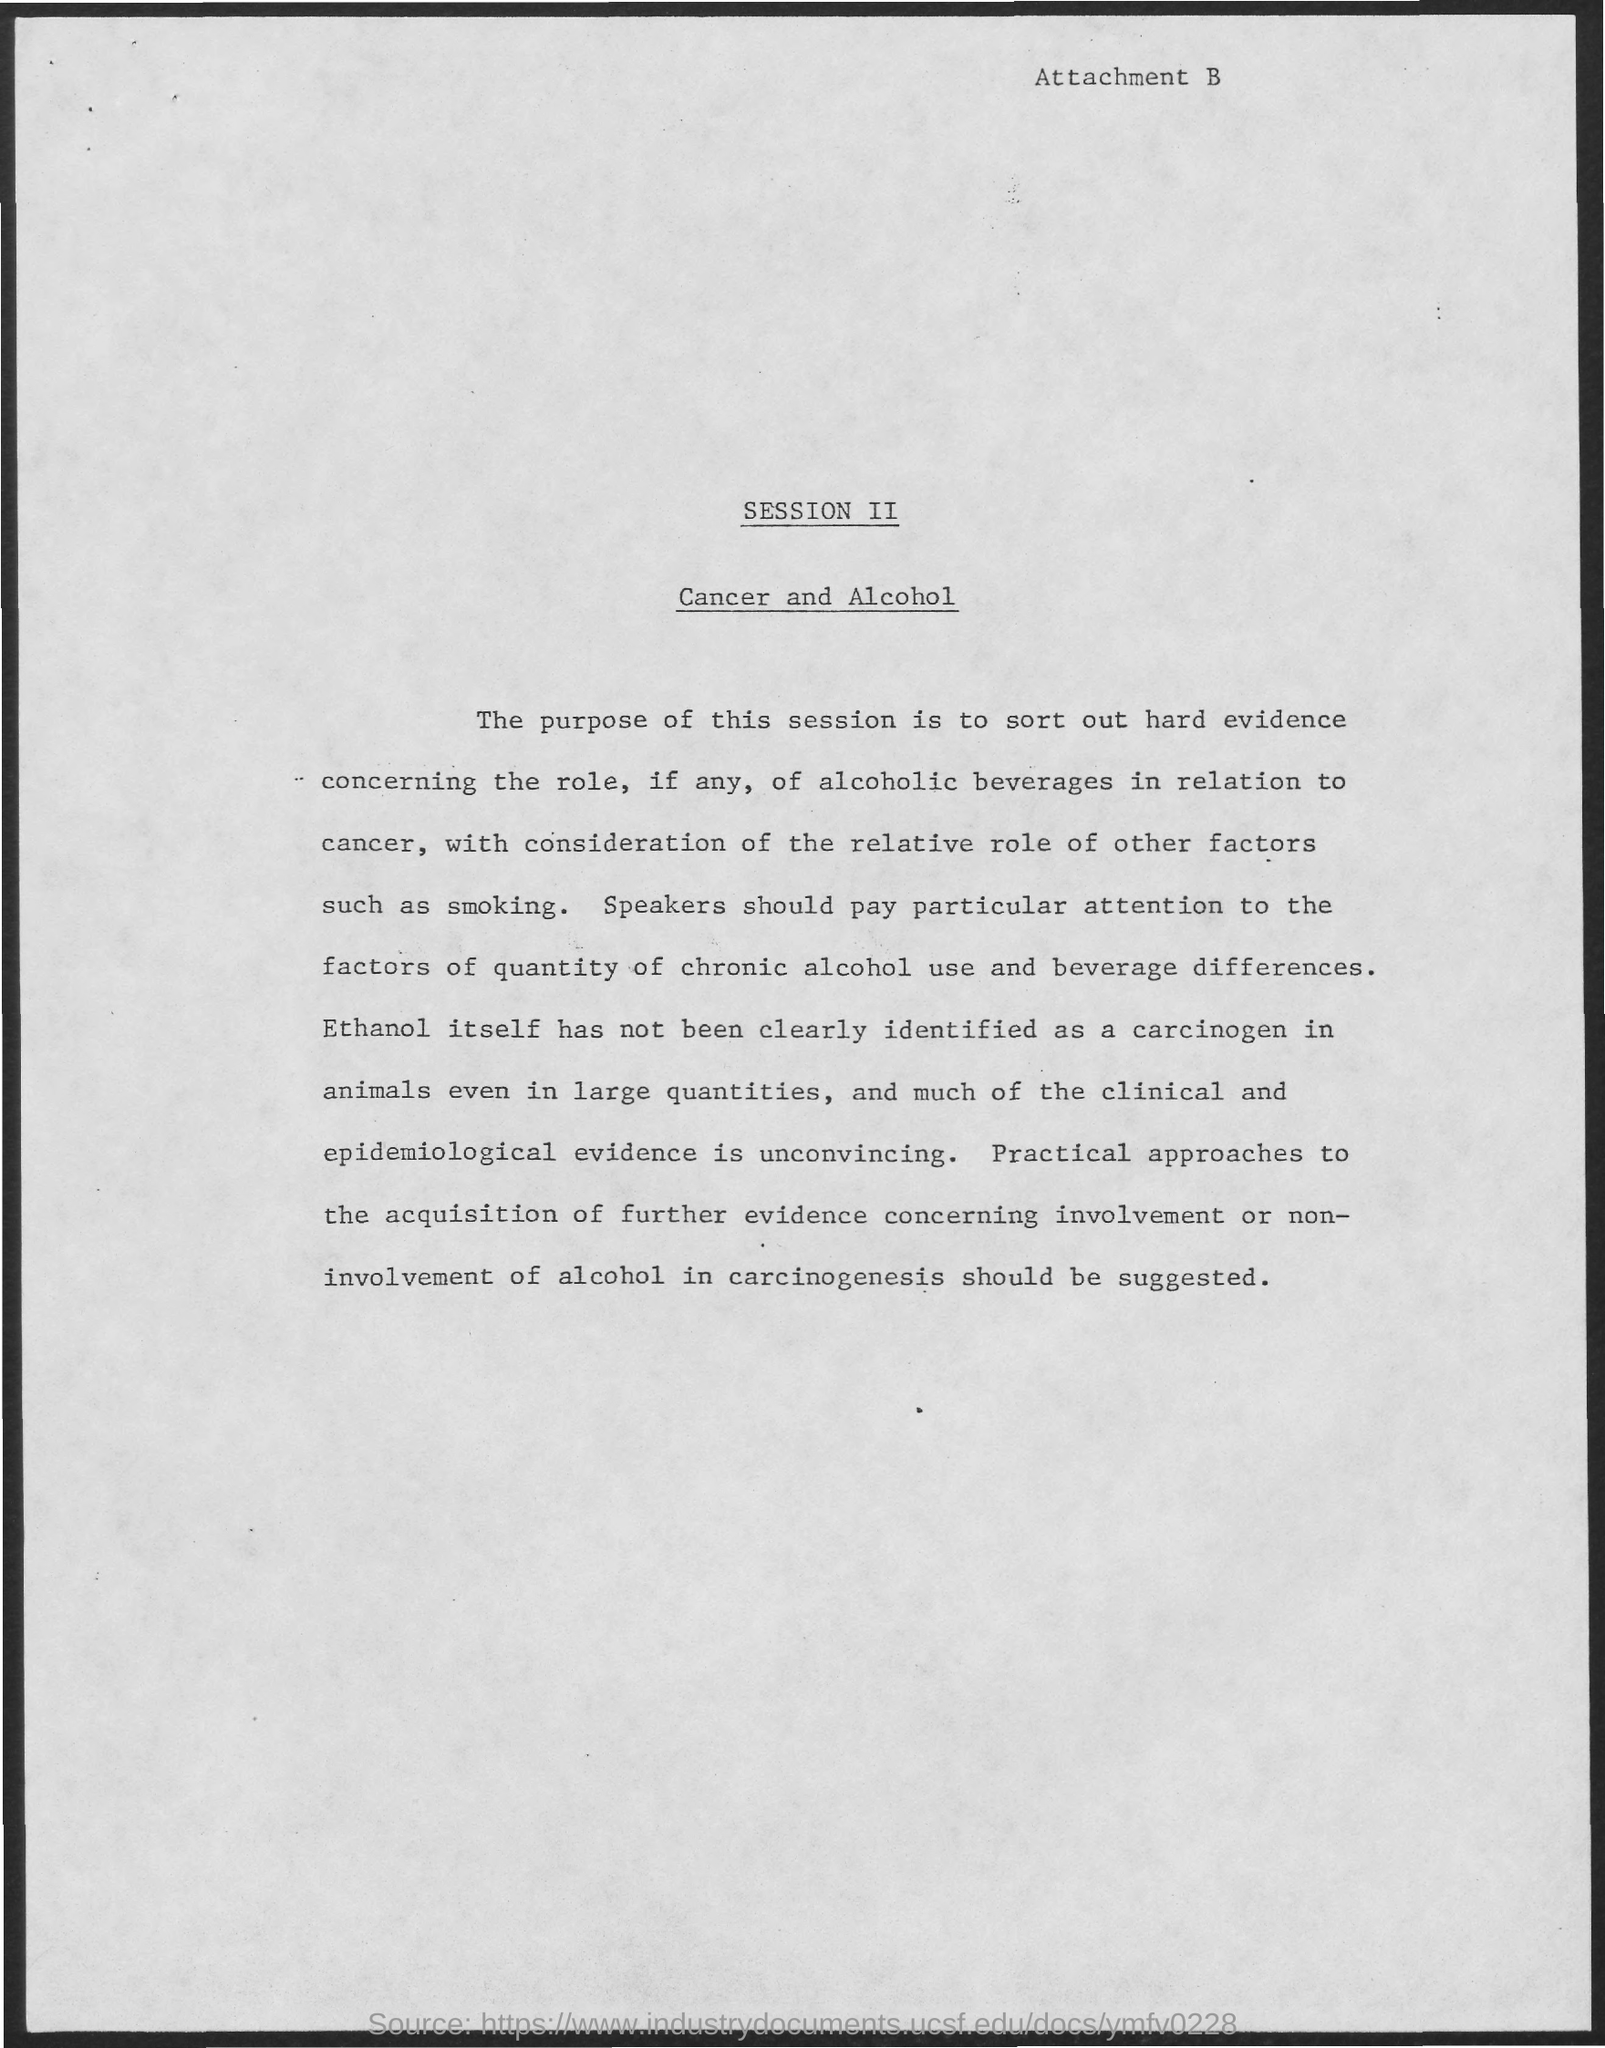What is written in the top of the document ?
Ensure brevity in your answer.  Attachment B. 